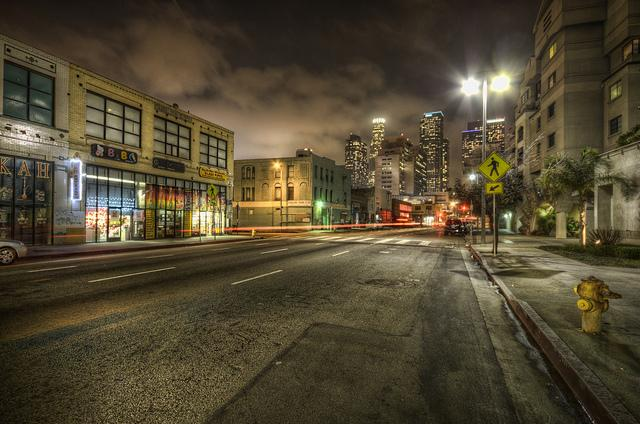What animal would you be most unlikely to see in this setting? Please explain your reasoning. tiger. You don't see a tiger on the streets. 